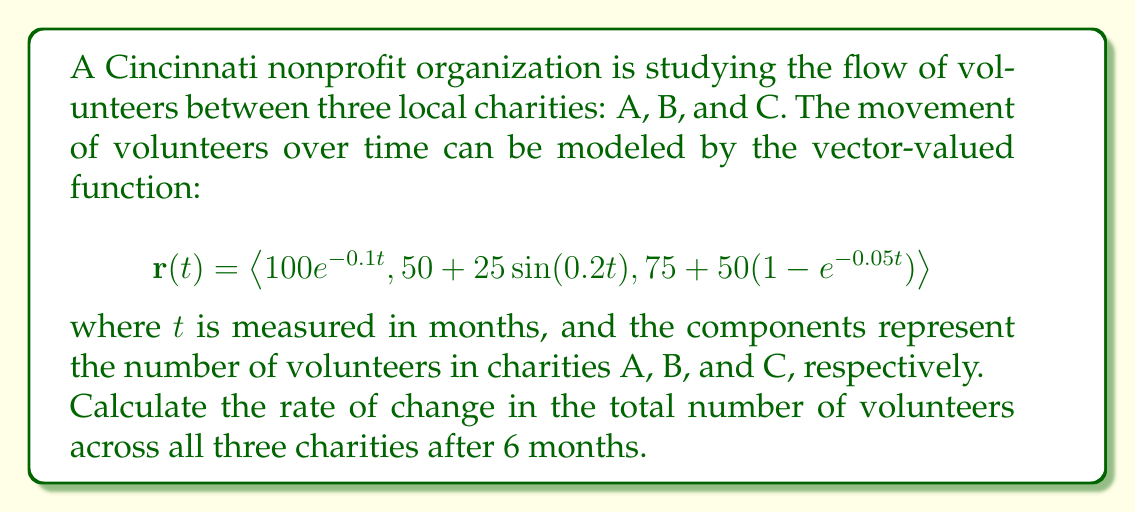Show me your answer to this math problem. To solve this problem, we need to follow these steps:

1) First, we need to find the total number of volunteers at any given time. This is the sum of the three components of the vector-valued function:

   $$T(t) = 100e^{-0.1t} + (50 + 25\sin(0.2t)) + (75 + 50(1-e^{-0.05t}))$$

2) To find the rate of change of the total number of volunteers, we need to differentiate $T(t)$ with respect to $t$:

   $$\frac{dT}{dt} = \frac{d}{dt}[100e^{-0.1t} + (50 + 25\sin(0.2t)) + (75 + 50(1-e^{-0.05t}))]$$

3) Using the rules of differentiation:

   $$\frac{dT}{dt} = -10e^{-0.1t} + 5\cos(0.2t) - 2.5e^{-0.05t}$$

4) Now, we need to evaluate this at $t = 6$ months:

   $$\frac{dT}{dt}\bigg|_{t=6} = -10e^{-0.1(6)} + 5\cos(0.2(6)) - 2.5e^{-0.05(6)}$$

5) Calculating each term:
   
   $-10e^{-0.1(6)} \approx -5.488$
   $5\cos(0.2(6)) \approx 2.234$
   $-2.5e^{-0.05(6)} \approx -1.896$

6) Sum these values:

   $$\frac{dT}{dt}\bigg|_{t=6} \approx -5.488 + 2.234 - 1.896 = -5.15$$

The negative value indicates that the total number of volunteers is decreasing at 6 months.
Answer: The rate of change in the total number of volunteers across all three charities after 6 months is approximately $-5.15$ volunteers per month. 